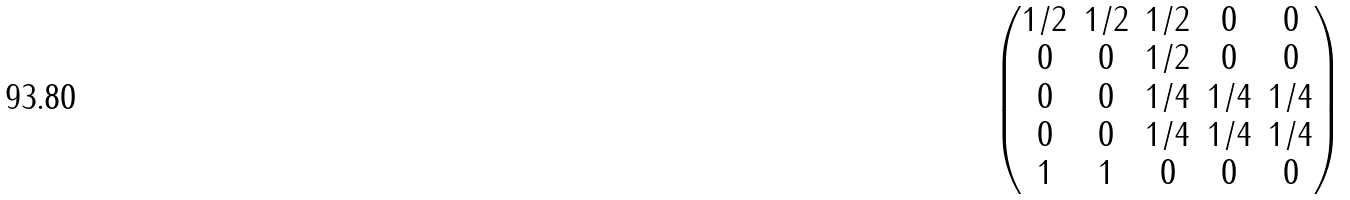Convert formula to latex. <formula><loc_0><loc_0><loc_500><loc_500>\begin{pmatrix} 1 / 2 & 1 / 2 & 1 / 2 & 0 & 0 \\ 0 & 0 & 1 / 2 & 0 & 0 \\ 0 & 0 & 1 / 4 & 1 / 4 & 1 / 4 \\ 0 & 0 & 1 / 4 & 1 / 4 & 1 / 4 \\ 1 & 1 & 0 & 0 & 0 \end{pmatrix}</formula> 